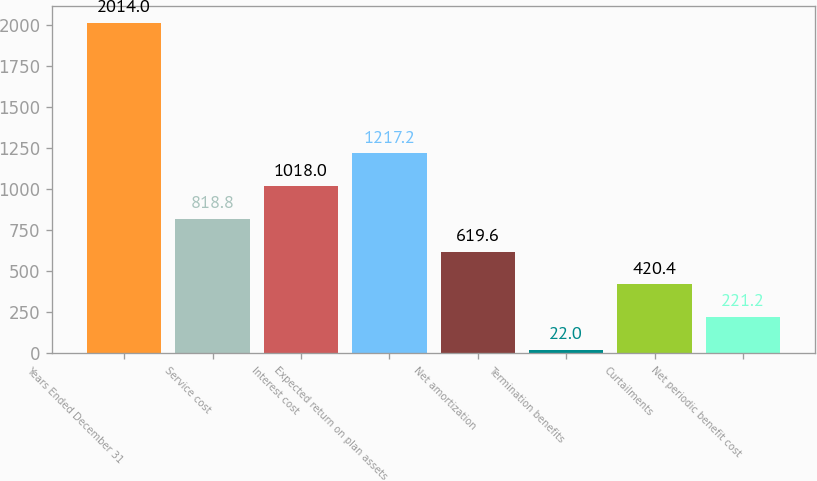Convert chart. <chart><loc_0><loc_0><loc_500><loc_500><bar_chart><fcel>Years Ended December 31<fcel>Service cost<fcel>Interest cost<fcel>Expected return on plan assets<fcel>Net amortization<fcel>Termination benefits<fcel>Curtailments<fcel>Net periodic benefit cost<nl><fcel>2014<fcel>818.8<fcel>1018<fcel>1217.2<fcel>619.6<fcel>22<fcel>420.4<fcel>221.2<nl></chart> 